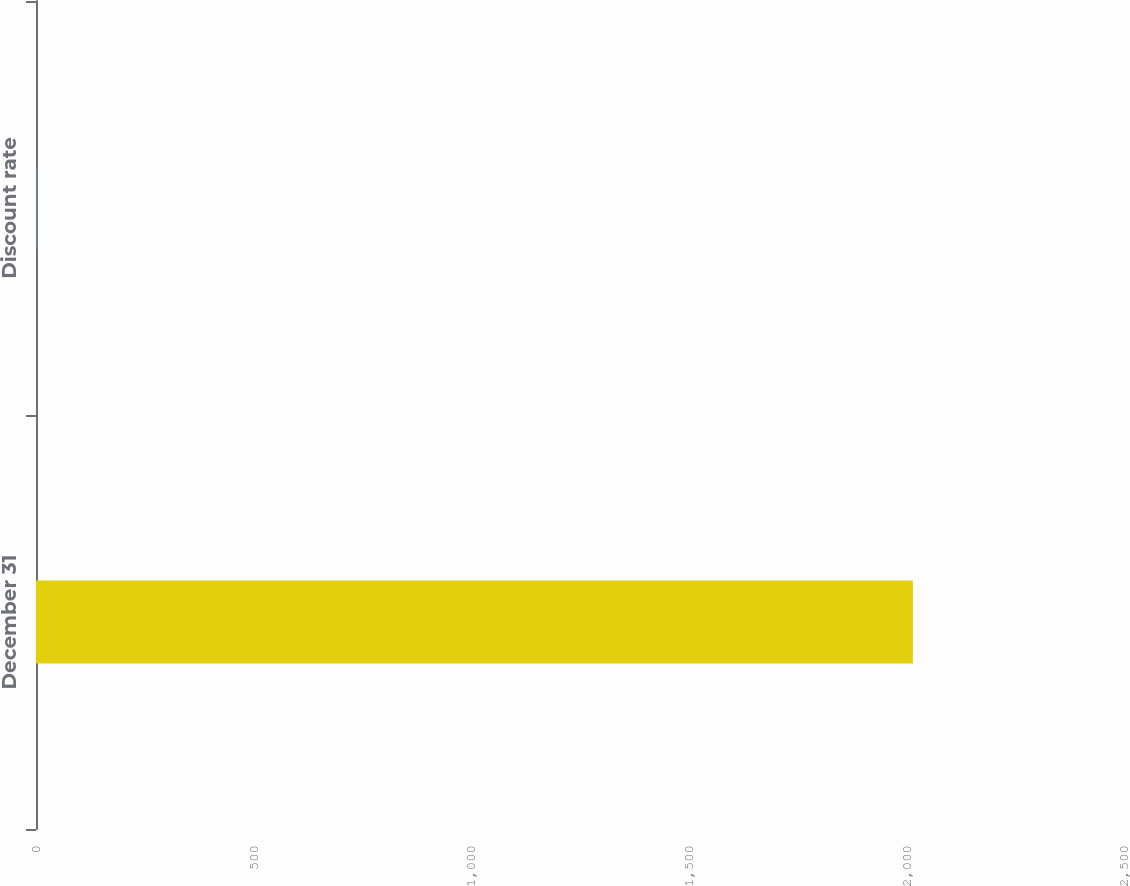<chart> <loc_0><loc_0><loc_500><loc_500><bar_chart><fcel>December 31<fcel>Discount rate<nl><fcel>2015<fcel>4<nl></chart> 